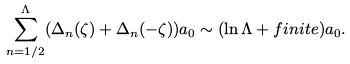Convert formula to latex. <formula><loc_0><loc_0><loc_500><loc_500>\sum _ { n = 1 / 2 } ^ { \Lambda } ( \Delta _ { n } ( \zeta ) + \Delta _ { n } ( - \zeta ) ) a _ { 0 } \sim ( \ln \Lambda + f i n i t e ) a _ { 0 } .</formula> 